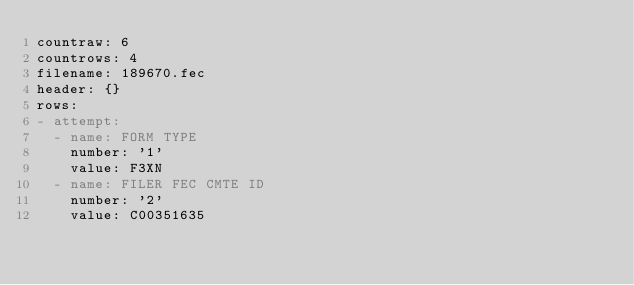Convert code to text. <code><loc_0><loc_0><loc_500><loc_500><_YAML_>countraw: 6
countrows: 4
filename: 189670.fec
header: {}
rows:
- attempt:
  - name: FORM TYPE
    number: '1'
    value: F3XN
  - name: FILER FEC CMTE ID
    number: '2'
    value: C00351635</code> 